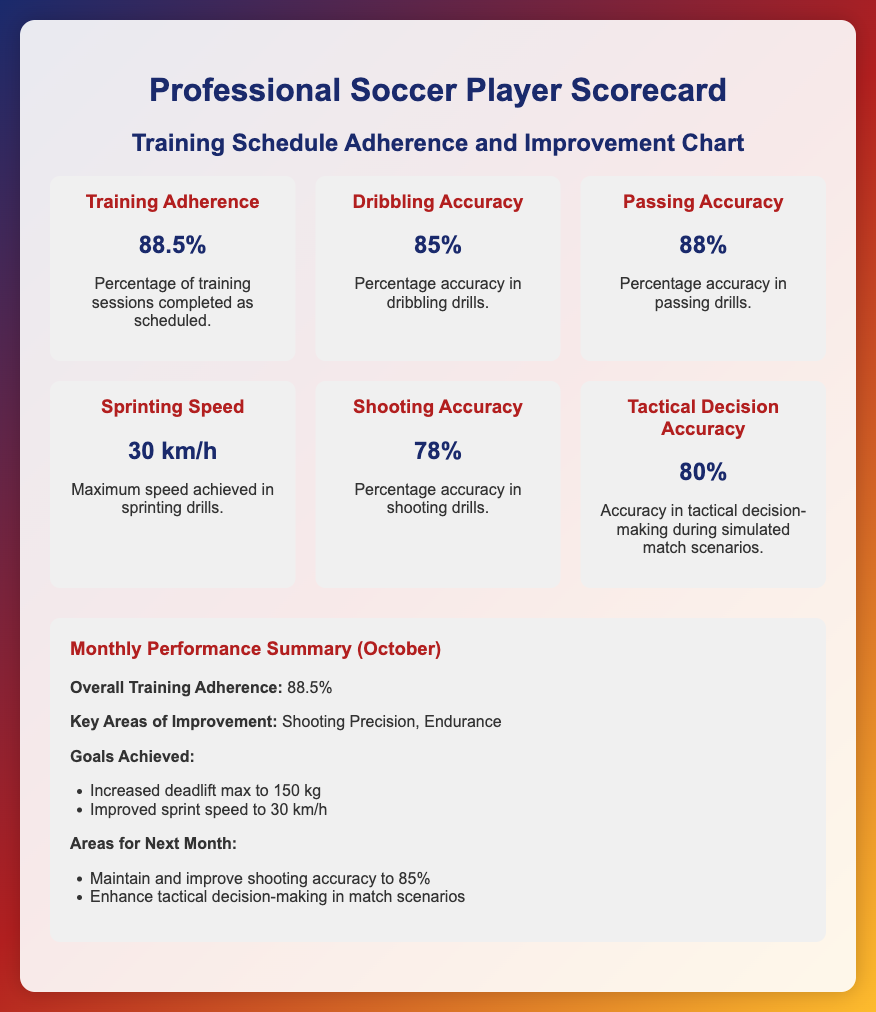What is the Training Adherence percentage? The Training Adherence is displayed as a percentage in the document, which indicates how many training sessions were completed as scheduled.
Answer: 88.5% What is the value for Dribbling Accuracy? Dribbling Accuracy is represented as a percentage in the scorecard, specifically showing how accurate the player is in dribbling drills.
Answer: 85% What are the key areas of improvement mentioned for this month? The document lists specific areas of improvement for the month, focusing on skills or aspects that need enhancement.
Answer: Shooting Precision, Endurance What is the maximum speed achieved in sprinting drills? The document indicates the highest speed obtained during sprinting drills, providing a clear metric of performance.
Answer: 30 km/h How is Tactical Decision Accuracy measured? The scorecard outlines how Tactical Decision Accuracy is calculated, analyzing the effectiveness in simulated match scenarios.
Answer: 80% What is the goal for shooting accuracy next month? The document sets a clear target for improvement in shooting accuracy for the following month.
Answer: 85% What was achieved regarding weightlifting this month? The summary indicates specific accomplishments related to strength training, particularly in weightlifting.
Answer: Increased deadlift max to 150 kg What is the overall adherence rate for the month of October? The document provides an overall adherence rate specifically for the month, summarizing performance over that period.
Answer: 88.5% What area will be focused on enhancing in match scenarios next month? The summary mentions specific aspects to improve upon next month, especially during match scenarios.
Answer: Tactical decision-making 